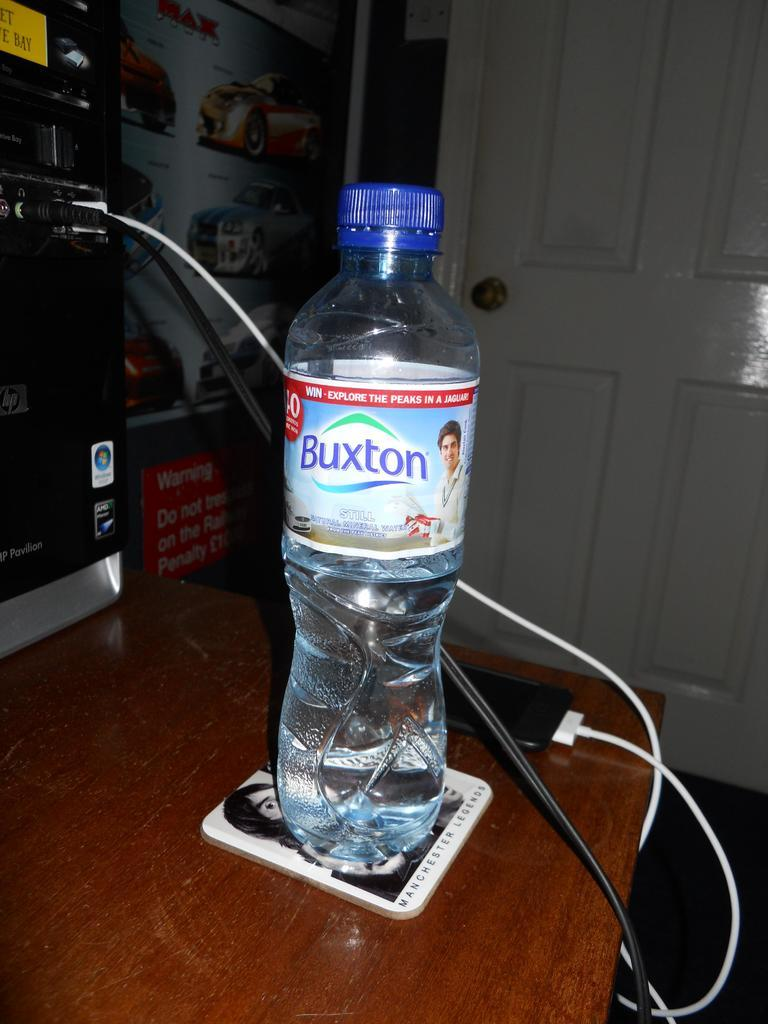<image>
Give a short and clear explanation of the subsequent image. A Buxton brand water bottle sits on a coaster 